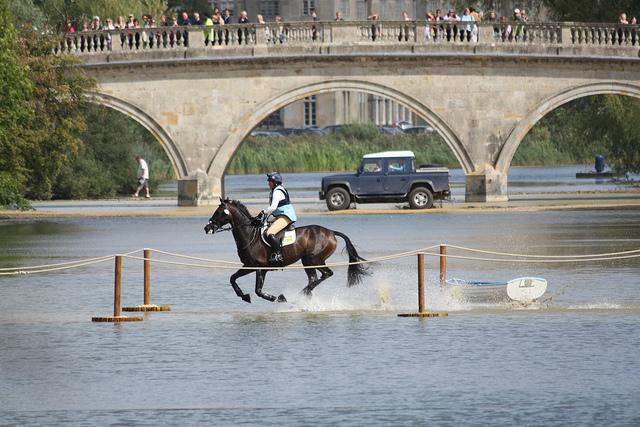Is the water deep?
Give a very brief answer. No. Why is he in the water?
Write a very short answer. Racing. Does that bridge look sturdy?
Quick response, please. Yes. 